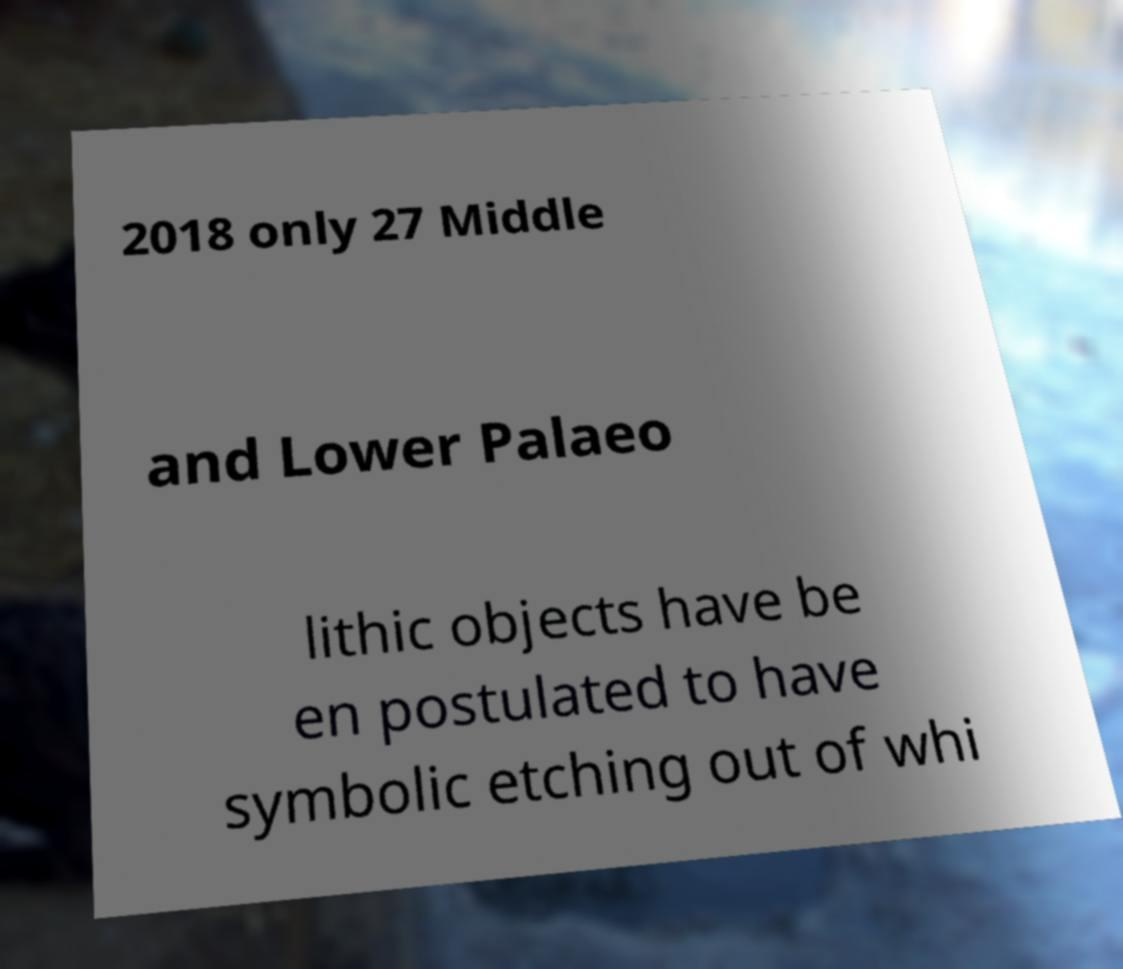Could you assist in decoding the text presented in this image and type it out clearly? 2018 only 27 Middle and Lower Palaeo lithic objects have be en postulated to have symbolic etching out of whi 